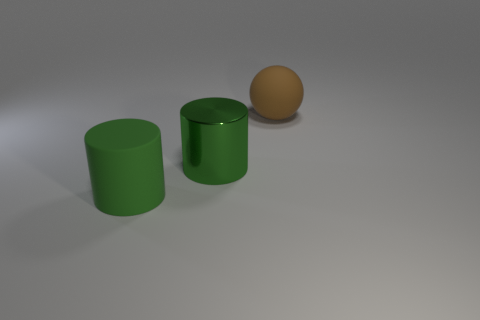Are there the same number of green rubber things that are behind the green metallic cylinder and metallic things that are behind the rubber ball?
Offer a terse response. Yes. What is the color of the matte thing that is the same shape as the green metal object?
Offer a terse response. Green. Is there anything else that is the same color as the big metallic cylinder?
Give a very brief answer. Yes. How many metallic things are either red balls or green things?
Provide a short and direct response. 1. Is the color of the ball the same as the shiny cylinder?
Give a very brief answer. No. Are there more large things left of the green metallic object than large yellow matte cylinders?
Keep it short and to the point. Yes. What number of other things are there of the same material as the large sphere
Provide a short and direct response. 1. What number of large things are either rubber spheres or green metallic objects?
Your answer should be very brief. 2. What number of large green metallic cylinders are right of the large rubber object in front of the big green metallic cylinder?
Provide a short and direct response. 1. Is there another big gray metal object that has the same shape as the metallic object?
Make the answer very short. No. 